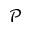<formula> <loc_0><loc_0><loc_500><loc_500>\mathcal { P }</formula> 